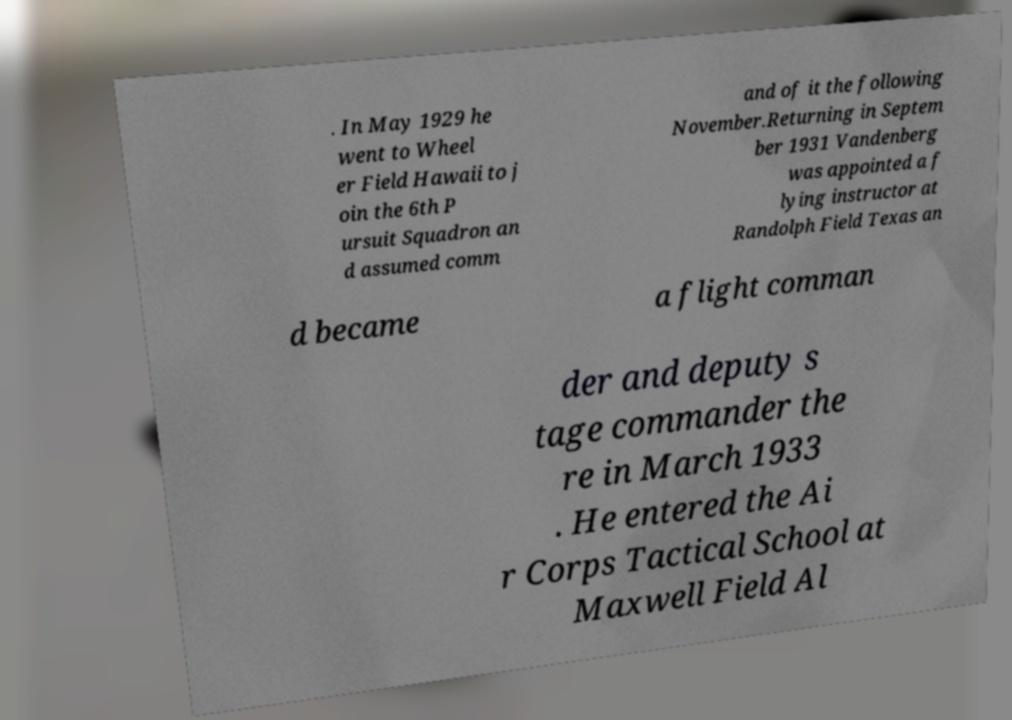Please identify and transcribe the text found in this image. . In May 1929 he went to Wheel er Field Hawaii to j oin the 6th P ursuit Squadron an d assumed comm and of it the following November.Returning in Septem ber 1931 Vandenberg was appointed a f lying instructor at Randolph Field Texas an d became a flight comman der and deputy s tage commander the re in March 1933 . He entered the Ai r Corps Tactical School at Maxwell Field Al 